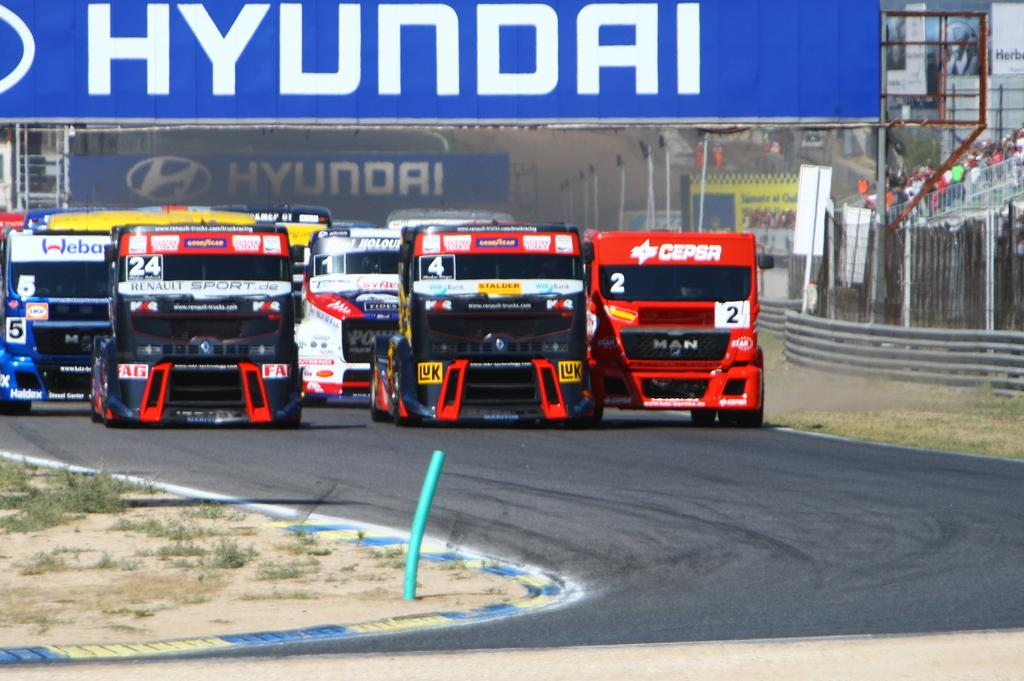What can be seen on the road in the image? There are vehicles on the road in the image. What type of vegetation is visible in the image? There is grass visible in the image. Where are the people located in the image? The people are on the right side of the image. What type of barrier is present in the image? There is a metal fence in the image. What is written at the top of the image? There is some written text visible at the top of the image. Can you tell me how many friends are involved in the fight depicted in the image? There is no fight or friends present in the image; it features vehicles on the road, grass, people, a metal fence, and written text. 